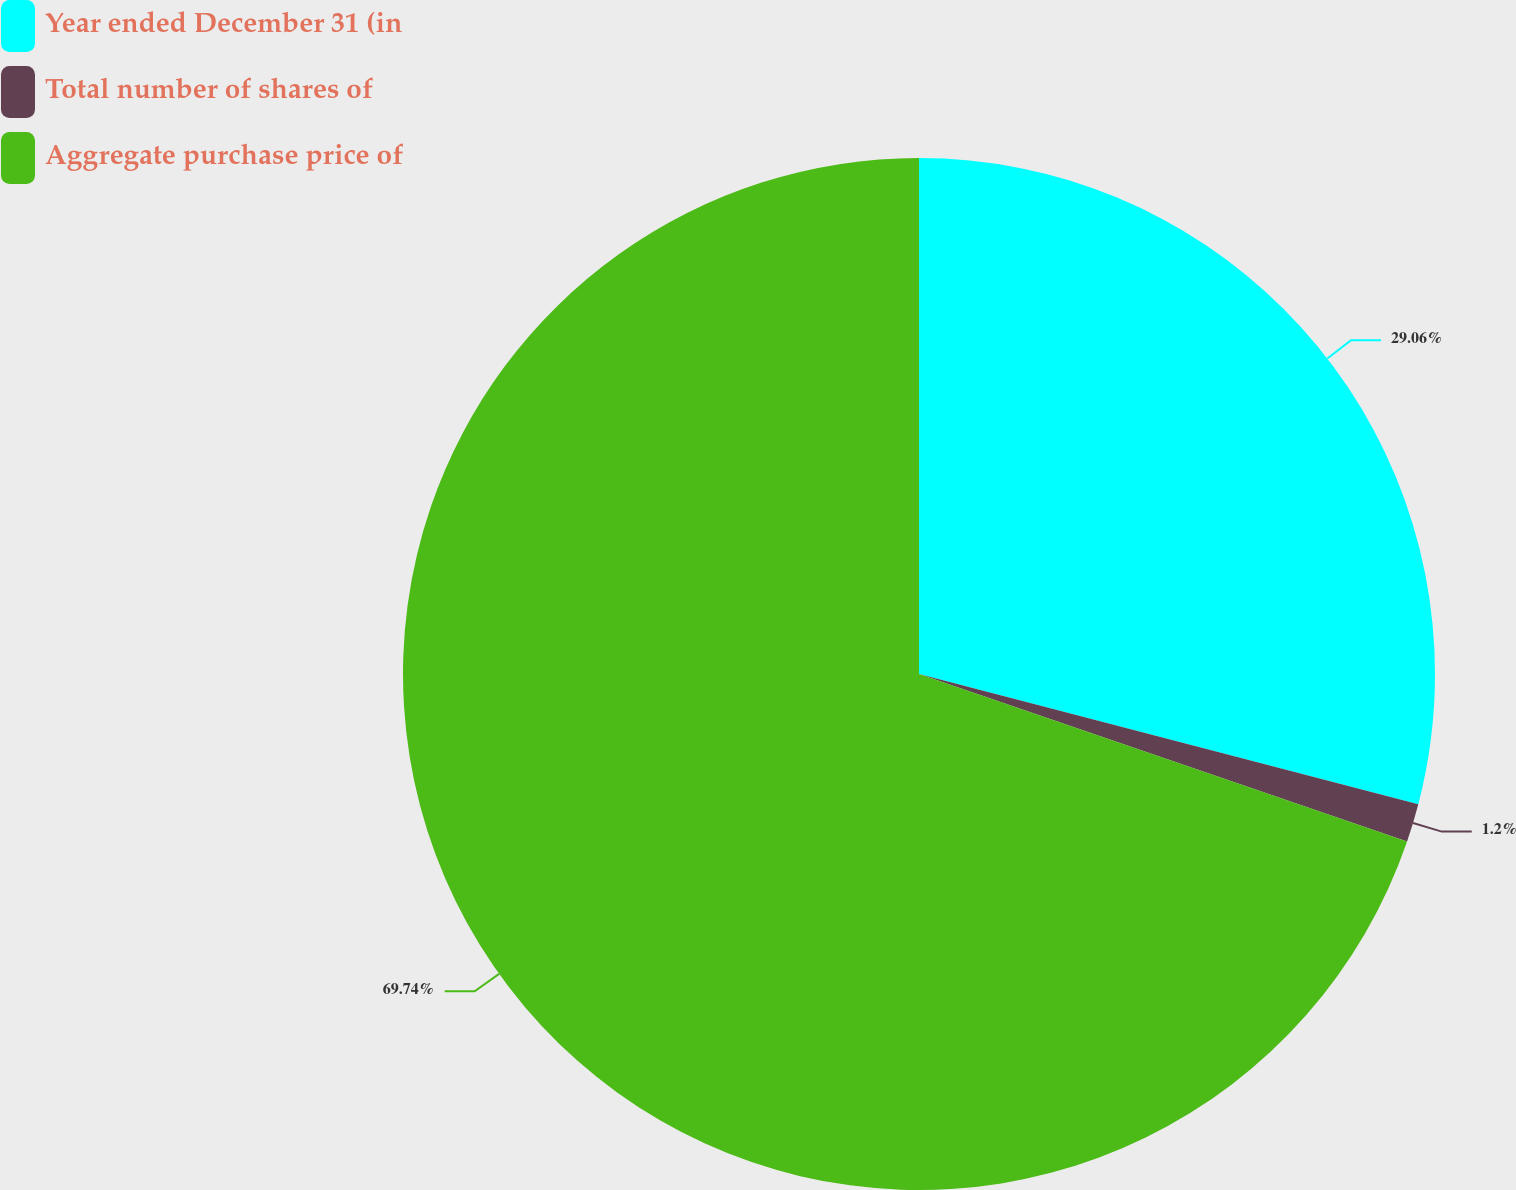Convert chart to OTSL. <chart><loc_0><loc_0><loc_500><loc_500><pie_chart><fcel>Year ended December 31 (in<fcel>Total number of shares of<fcel>Aggregate purchase price of<nl><fcel>29.06%<fcel>1.2%<fcel>69.74%<nl></chart> 